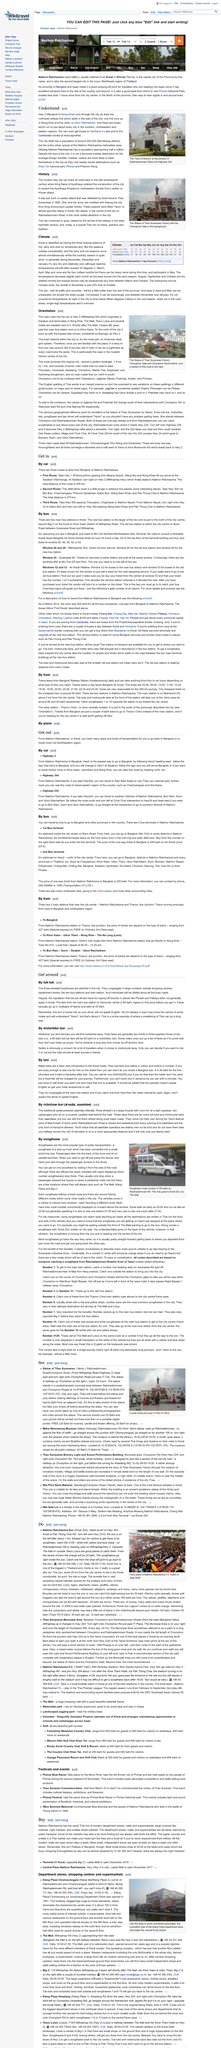List a handful of essential elements in this visual. The Klang Plaza Chomsurang Department Store was opened in 1991. The "Yamo Entrance" is located at the junction of Ratchadamnoen Road and Highway 224, where those two roads meet. It is possible to travel to the city by train as there are two main stations located near the city center. With certainty, a blue and yellow taxi can be located at the main bus station. May is the month that can experience particularly wet weather. 